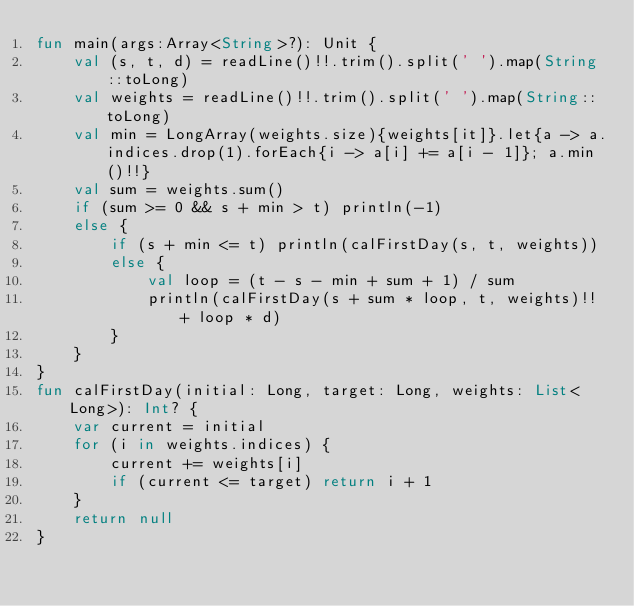Convert code to text. <code><loc_0><loc_0><loc_500><loc_500><_Kotlin_>fun main(args:Array<String>?): Unit {
    val (s, t, d) = readLine()!!.trim().split(' ').map(String::toLong)
    val weights = readLine()!!.trim().split(' ').map(String::toLong)
    val min = LongArray(weights.size){weights[it]}.let{a -> a.indices.drop(1).forEach{i -> a[i] += a[i - 1]}; a.min()!!}
    val sum = weights.sum()
    if (sum >= 0 && s + min > t) println(-1)
    else {
        if (s + min <= t) println(calFirstDay(s, t, weights))
        else {
            val loop = (t - s - min + sum + 1) / sum
            println(calFirstDay(s + sum * loop, t, weights)!! + loop * d)
        }
    }
}
fun calFirstDay(initial: Long, target: Long, weights: List<Long>): Int? {
    var current = initial
    for (i in weights.indices) {
        current += weights[i]
        if (current <= target) return i + 1
    }
    return null
}

</code> 